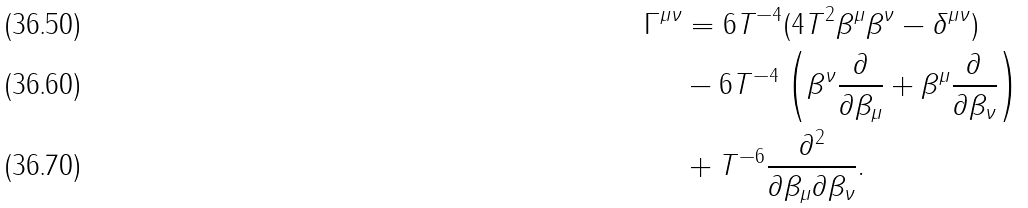Convert formula to latex. <formula><loc_0><loc_0><loc_500><loc_500>\Gamma ^ { \mu \nu } & = 6 T ^ { - 4 } ( 4 T ^ { 2 } \beta ^ { \mu } \beta ^ { \nu } - \delta ^ { \mu \nu } ) \\ & - 6 T ^ { - 4 } \left ( \beta ^ { \nu } \frac { \partial } { \partial \beta _ { \mu } } + \beta ^ { \mu } \frac { \partial } { \partial \beta _ { \nu } } \right ) \\ & + T ^ { - 6 } \frac { \partial ^ { 2 } } { \partial \beta _ { \mu } \partial \beta _ { \nu } } .</formula> 